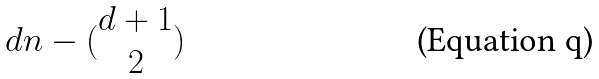Convert formula to latex. <formula><loc_0><loc_0><loc_500><loc_500>d n - ( \begin{matrix} d + 1 \\ 2 \end{matrix} )</formula> 